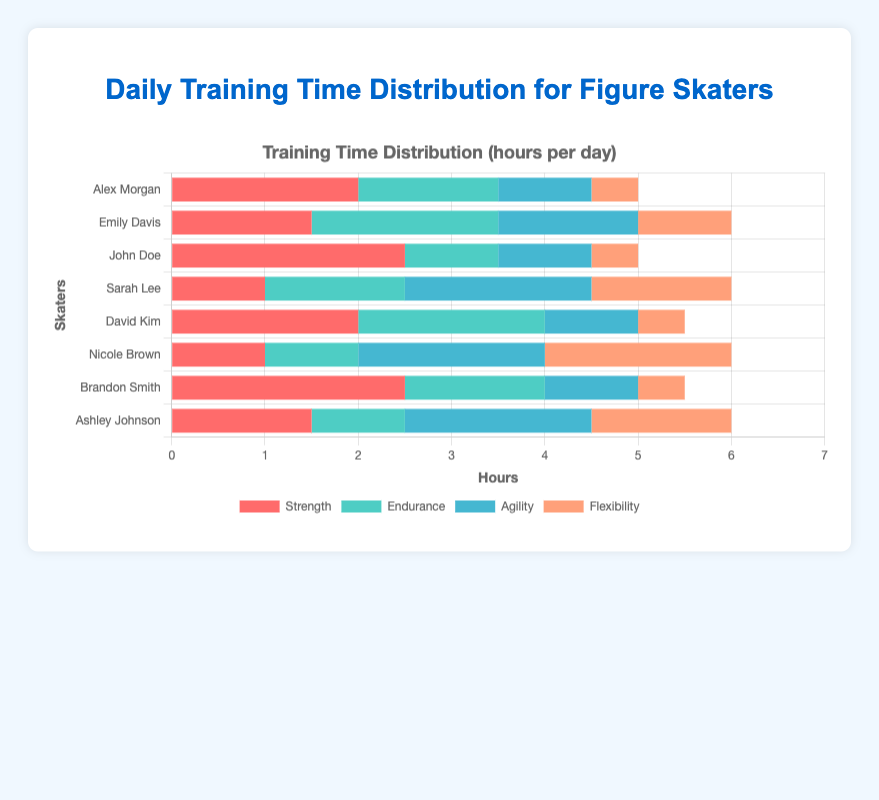What is the total training time per day for Emily Davis? To find the total training time per day for Emily Davis, add the hours dedicated to each skill: Strength (1.5) + Endurance (2) + Agility (1.5) + Flexibility (1). This results in 6 hours per day.
Answer: 6 Who spends the most time on flexibility training? To determine who spends the most time on flexibility, look at the flexibility bars for each skater. Nicole Brown and Sarah Lee both spend 2 hours per day on flexibility.
Answer: Nicole Brown, Sarah Lee Which skater has the highest combined training time for strength and agility? Combine the Strength and Agility training times for each skater. Alex Morgan: 2 + 1 = 3; Emily Davis: 1.5 + 1.5 = 3; John Doe: 2.5 + 1 = 3.5; Sarah Lee: 1 + 2 = 3; David Kim: 2 + 1 = 3; Nicole Brown: 1 + 2 = 3; Brandon Smith: 2.5 + 1 = 3.5; Ashley Johnson: 1.5 + 2 = 3.5. John Doe, Brandon Smith, and Ashley Johnson have the highest combined times of 3.5 hours.
Answer: John Doe, Brandon Smith, Ashley Johnson How does Sarah Lee's agility training time compare to Ashley Johnson's? Compare the agility training times directly. Sarah Lee has 2 hours of agility training while Ashley Johnson also has 2 hours of agility training.
Answer: Equal (both have 2 hours) Who spends the least amount of time on endurance training? To identify who spends the least amount of time on endurance, check the endurance bars. John Doe, Nicole Brown, and Ashley Johnson each spend 1 hour per day on endurance.
Answer: John Doe, Nicole Brown, Ashley Johnson Compare the total training time between David Kim and Brandon Smith. Sum the training times for each individual. David Kim: Strength (2) + Endurance (2) + Agility (1) + Flexibility (0.5) = 5.5 hours. Brandon Smith: Strength (2.5) + Endurance (1.5) + Agility (1) + Flexibility (0.5) = 5.5 hours. Both spend a total of 5.5 hours.
Answer: Equal (both spend 5.5 hours) What is the average of agility training time across all skaters? Add all agility training times and divide by the number of skaters: (1 + 1.5 + 1 + 2 + 1 + 2 + 1 + 2) / 8 = 11.5 / 8 = 1.4375.
Answer: 1.4375 Who spends more time on strength training: Alex Morgan or John Doe? Compare the strength training times. Alex Morgan spends 2 hours, while John Doe spends 2.5 hours. John Doe spends more time.
Answer: John Doe Which category receives the most total training time, considering all skaters? Sum the training times for each category. Strength: (2 + 1.5 + 2.5 + 1 + 2 + 1 + 2.5 + 1.5) = 14; Endurance: (1.5 + 2 + 1 + 1.5 + 2 + 1 + 1.5 + 1) = 11.5; Agility: (1 + 1.5 + 1 + 2 + 1 + 2 + 1 + 2) = 11.5; Flexibility: (0.5 + 1 + 0.5 + 1.5 + 0.5 + 2 + 0.5 + 1.5) = 8. Strength receives the most total training time.
Answer: Strength 